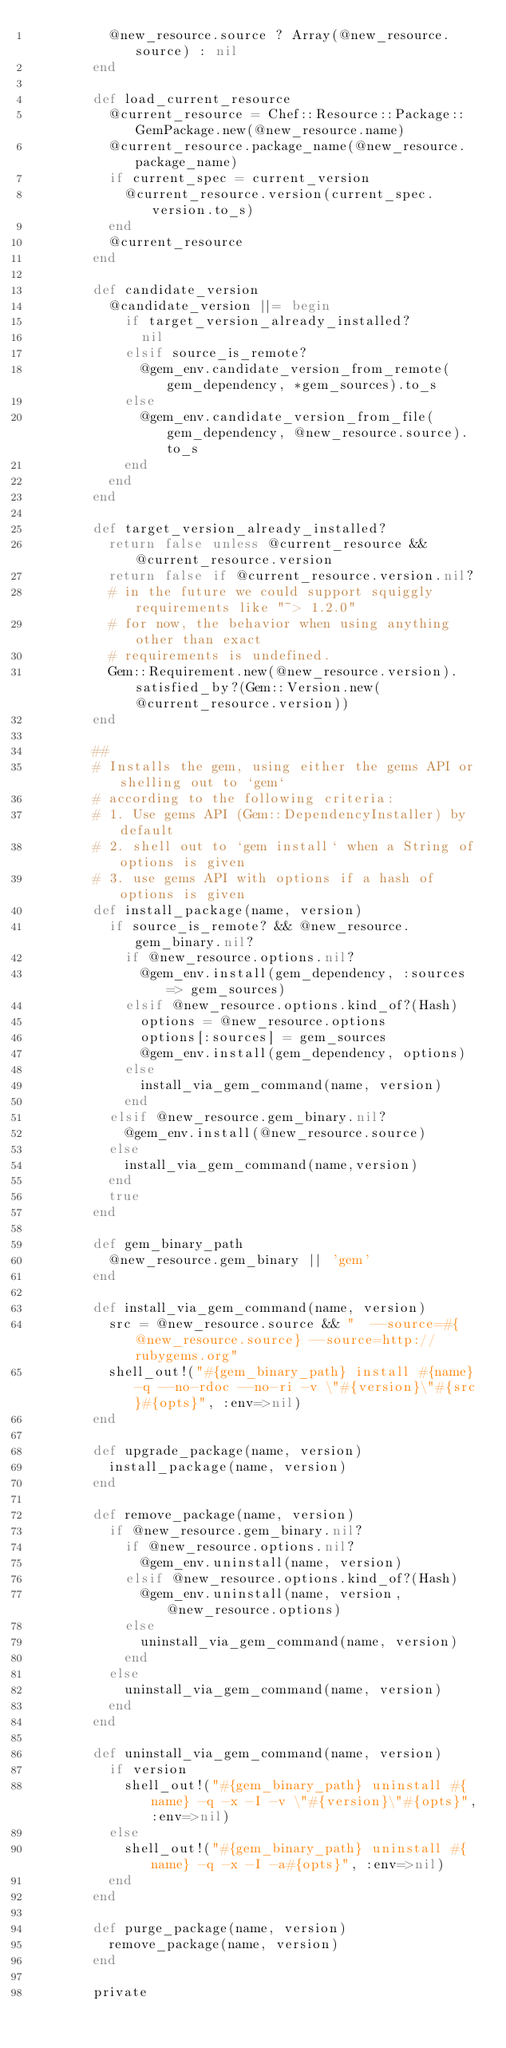Convert code to text. <code><loc_0><loc_0><loc_500><loc_500><_Ruby_>          @new_resource.source ? Array(@new_resource.source) : nil
        end

        def load_current_resource
          @current_resource = Chef::Resource::Package::GemPackage.new(@new_resource.name)
          @current_resource.package_name(@new_resource.package_name)
          if current_spec = current_version
            @current_resource.version(current_spec.version.to_s)
          end
          @current_resource
        end

        def candidate_version
          @candidate_version ||= begin
            if target_version_already_installed?
              nil
            elsif source_is_remote?
              @gem_env.candidate_version_from_remote(gem_dependency, *gem_sources).to_s
            else
              @gem_env.candidate_version_from_file(gem_dependency, @new_resource.source).to_s
            end
          end
        end

        def target_version_already_installed?
          return false unless @current_resource && @current_resource.version
          return false if @current_resource.version.nil?
          # in the future we could support squiggly requirements like "~> 1.2.0"
          # for now, the behavior when using anything other than exact 
          # requirements is undefined.
          Gem::Requirement.new(@new_resource.version).satisfied_by?(Gem::Version.new(@current_resource.version))
        end

        ##
        # Installs the gem, using either the gems API or shelling out to `gem`
        # according to the following criteria:
        # 1. Use gems API (Gem::DependencyInstaller) by default
        # 2. shell out to `gem install` when a String of options is given
        # 3. use gems API with options if a hash of options is given
        def install_package(name, version)
          if source_is_remote? && @new_resource.gem_binary.nil?
            if @new_resource.options.nil?
              @gem_env.install(gem_dependency, :sources => gem_sources)
            elsif @new_resource.options.kind_of?(Hash)
              options = @new_resource.options
              options[:sources] = gem_sources
              @gem_env.install(gem_dependency, options)
            else
              install_via_gem_command(name, version)
            end
          elsif @new_resource.gem_binary.nil?
            @gem_env.install(@new_resource.source)
          else
            install_via_gem_command(name,version)
          end
          true
        end

        def gem_binary_path
          @new_resource.gem_binary || 'gem'
        end

        def install_via_gem_command(name, version)
          src = @new_resource.source && "  --source=#{@new_resource.source} --source=http://rubygems.org"
          shell_out!("#{gem_binary_path} install #{name} -q --no-rdoc --no-ri -v \"#{version}\"#{src}#{opts}", :env=>nil)
        end

        def upgrade_package(name, version)
          install_package(name, version)
        end

        def remove_package(name, version)
          if @new_resource.gem_binary.nil?
            if @new_resource.options.nil?
              @gem_env.uninstall(name, version)
            elsif @new_resource.options.kind_of?(Hash)
              @gem_env.uninstall(name, version, @new_resource.options)
            else
              uninstall_via_gem_command(name, version)
            end
          else
            uninstall_via_gem_command(name, version)
          end
        end

        def uninstall_via_gem_command(name, version)
          if version
            shell_out!("#{gem_binary_path} uninstall #{name} -q -x -I -v \"#{version}\"#{opts}", :env=>nil)
          else
            shell_out!("#{gem_binary_path} uninstall #{name} -q -x -I -a#{opts}", :env=>nil)
          end
        end

        def purge_package(name, version)
          remove_package(name, version)
        end

        private
</code> 